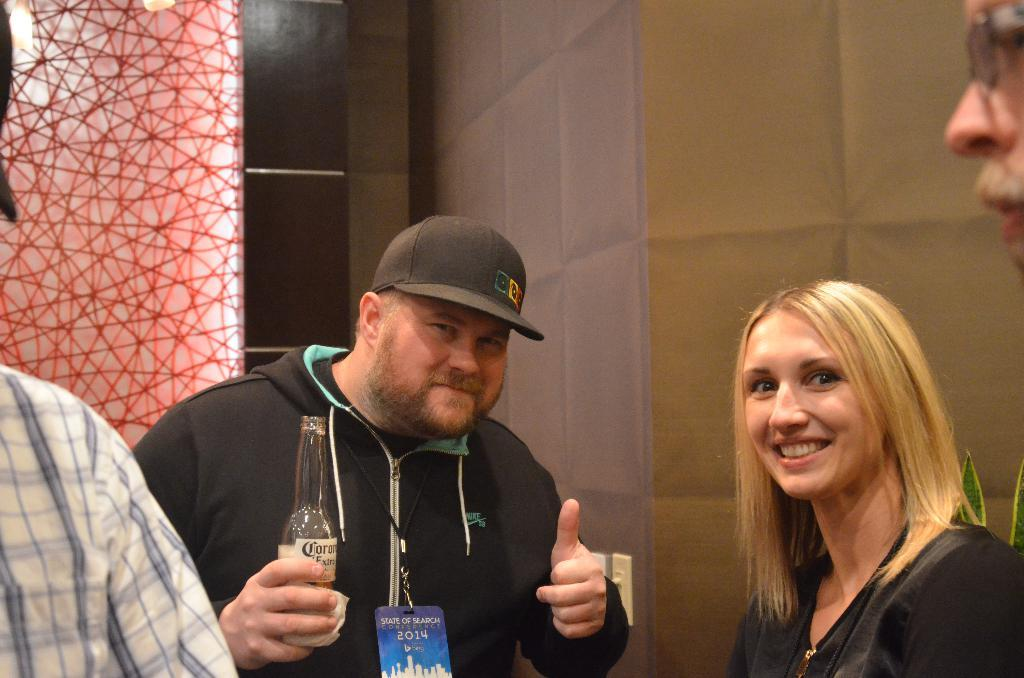How many people are in the image? There are people in the image, but the exact number is not specified. What is one person holding in the image? One person is holding a bottle in the image. What type of plant can be seen in the image? There is a house plant in the image. What is the board in the image used for? The purpose of the board in the image is not specified. What is the background of the image made of? There is a wall in the image, which suggests that the background is made of a solid material like brick or concrete. How many horses are in the image? There are no horses present in the image. 